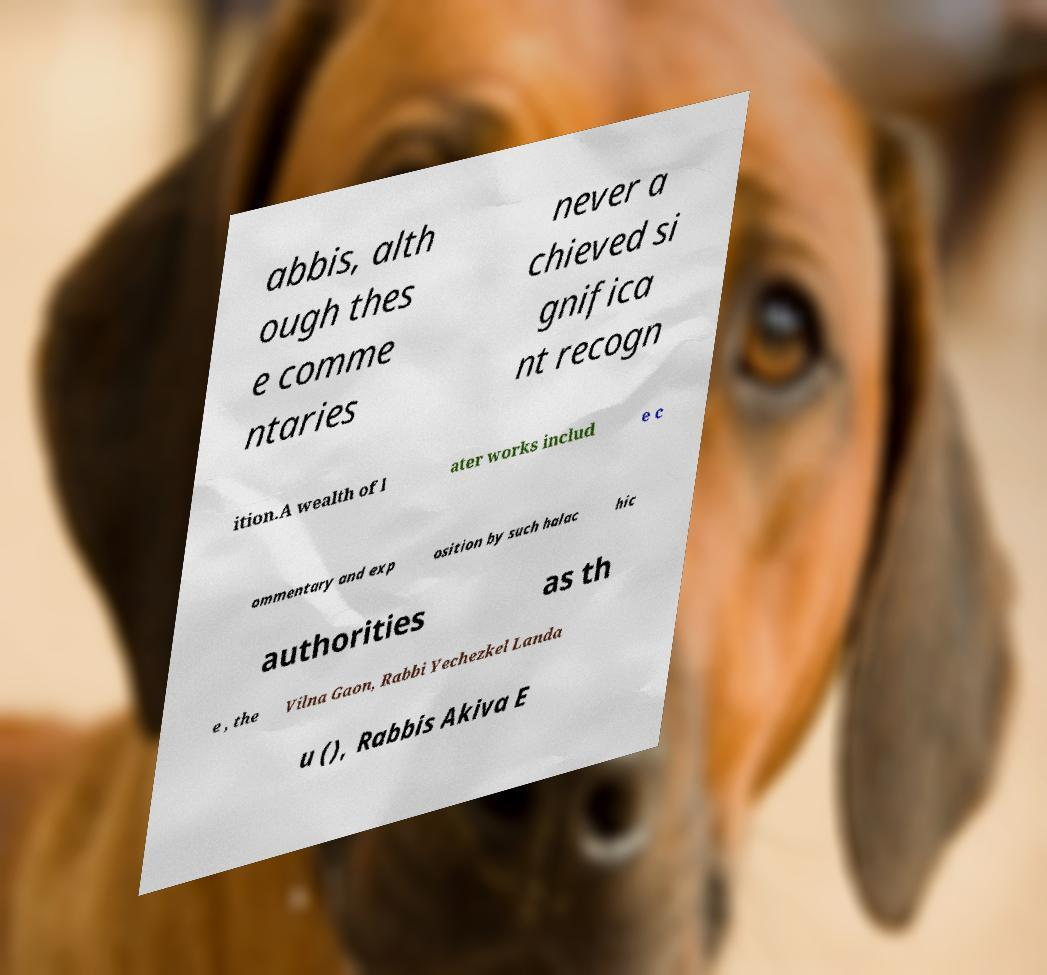What messages or text are displayed in this image? I need them in a readable, typed format. abbis, alth ough thes e comme ntaries never a chieved si gnifica nt recogn ition.A wealth of l ater works includ e c ommentary and exp osition by such halac hic authorities as th e , the Vilna Gaon, Rabbi Yechezkel Landa u (), Rabbis Akiva E 